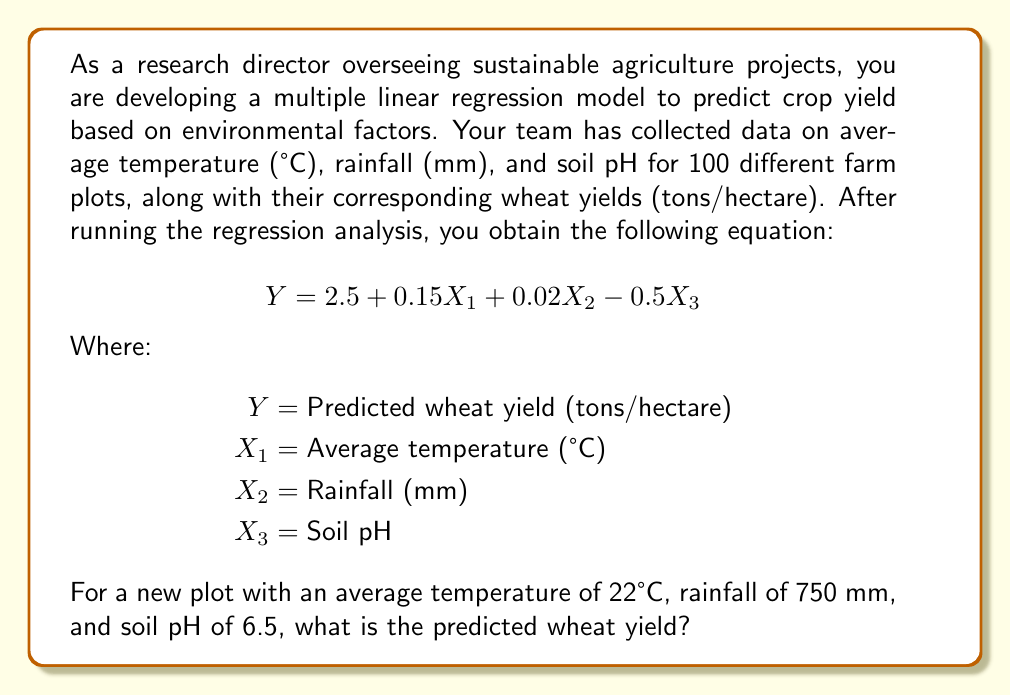Provide a solution to this math problem. To solve this problem, we need to use the multiple linear regression equation provided and substitute the given values for each variable. Let's break it down step by step:

1. Recall the equation:
   $$Y = 2.5 + 0.15X_1 + 0.02X_2 - 0.5X_3$$

2. Substitute the given values:
   $X_1 = 22$ (Average temperature in °C)
   $X_2 = 750$ (Rainfall in mm)
   $X_3 = 6.5$ (Soil pH)

3. Now, let's plug these values into the equation:
   $$Y = 2.5 + 0.15(22) + 0.02(750) - 0.5(6.5)$$

4. Solve each term:
   - $0.15(22) = 3.3$
   - $0.02(750) = 15$
   - $0.5(6.5) = 3.25$

5. Substitute these values back into the equation:
   $$Y = 2.5 + 3.3 + 15 - 3.25$$

6. Sum up all the terms:
   $$Y = 17.55$$

Therefore, the predicted wheat yield for the new plot is 17.55 tons per hectare.
Answer: 17.55 tons/hectare 